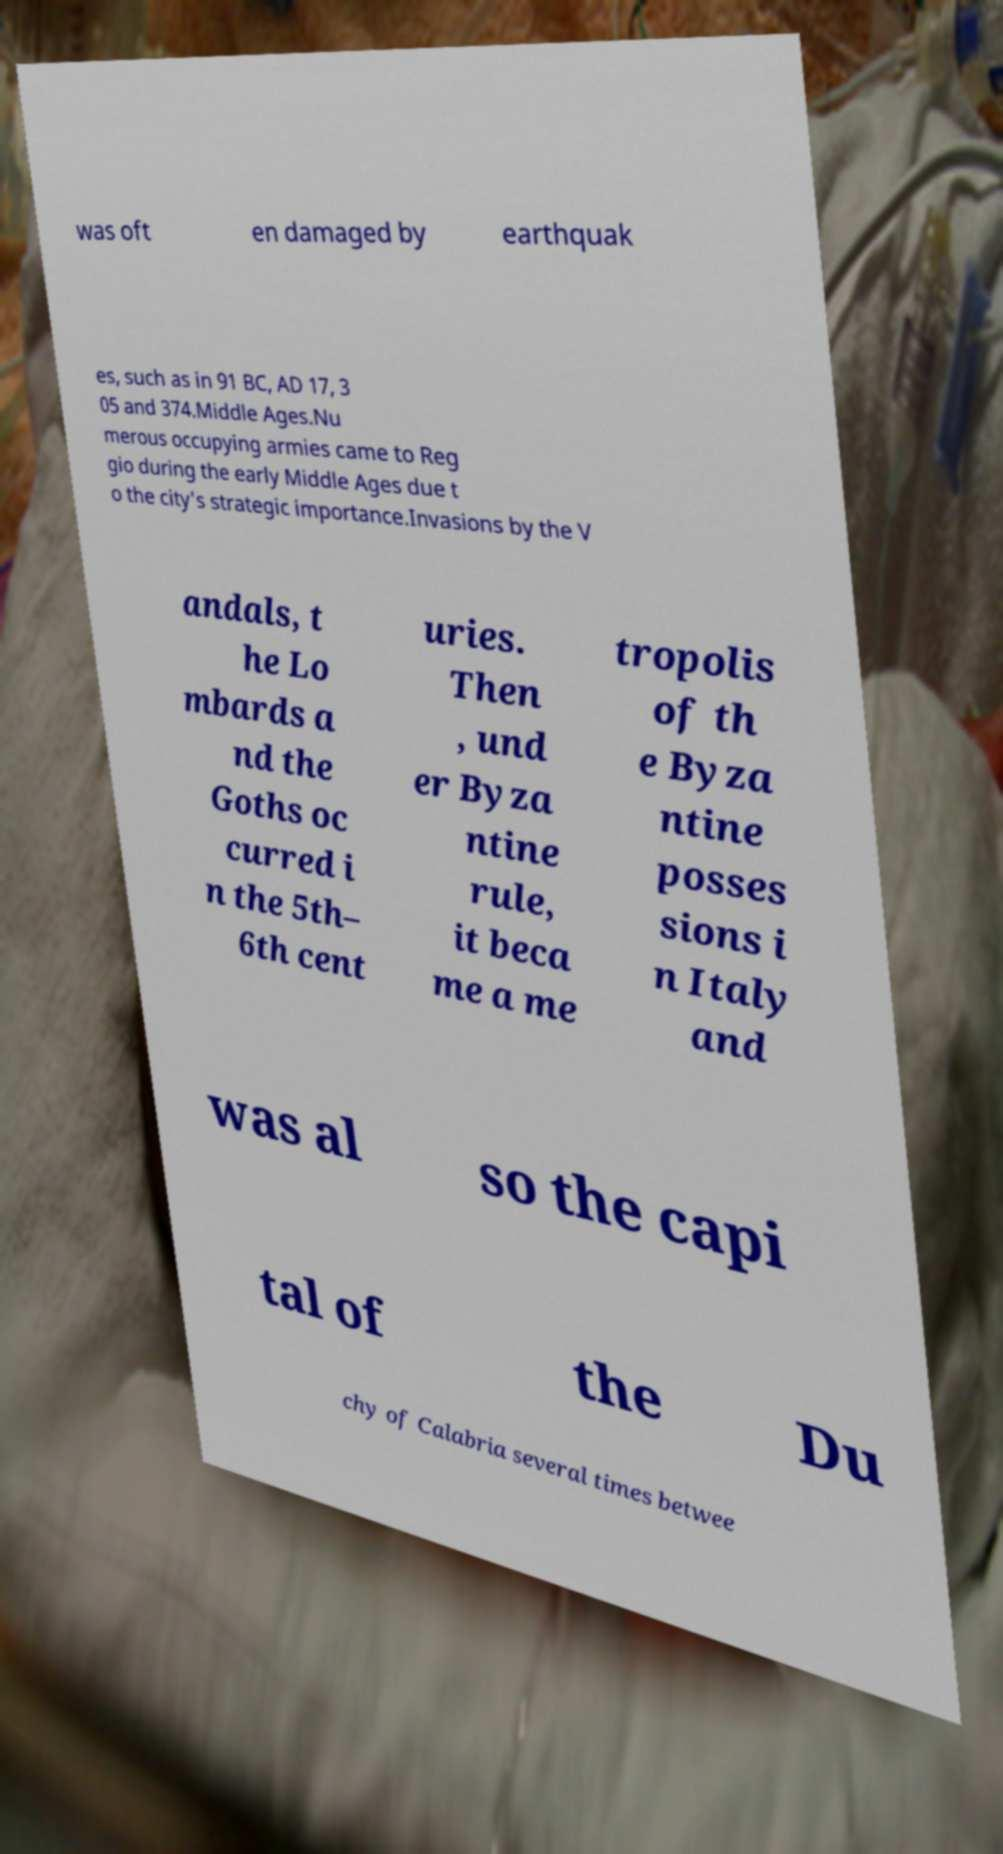Can you accurately transcribe the text from the provided image for me? was oft en damaged by earthquak es, such as in 91 BC, AD 17, 3 05 and 374.Middle Ages.Nu merous occupying armies came to Reg gio during the early Middle Ages due t o the city's strategic importance.Invasions by the V andals, t he Lo mbards a nd the Goths oc curred i n the 5th– 6th cent uries. Then , und er Byza ntine rule, it beca me a me tropolis of th e Byza ntine posses sions i n Italy and was al so the capi tal of the Du chy of Calabria several times betwee 